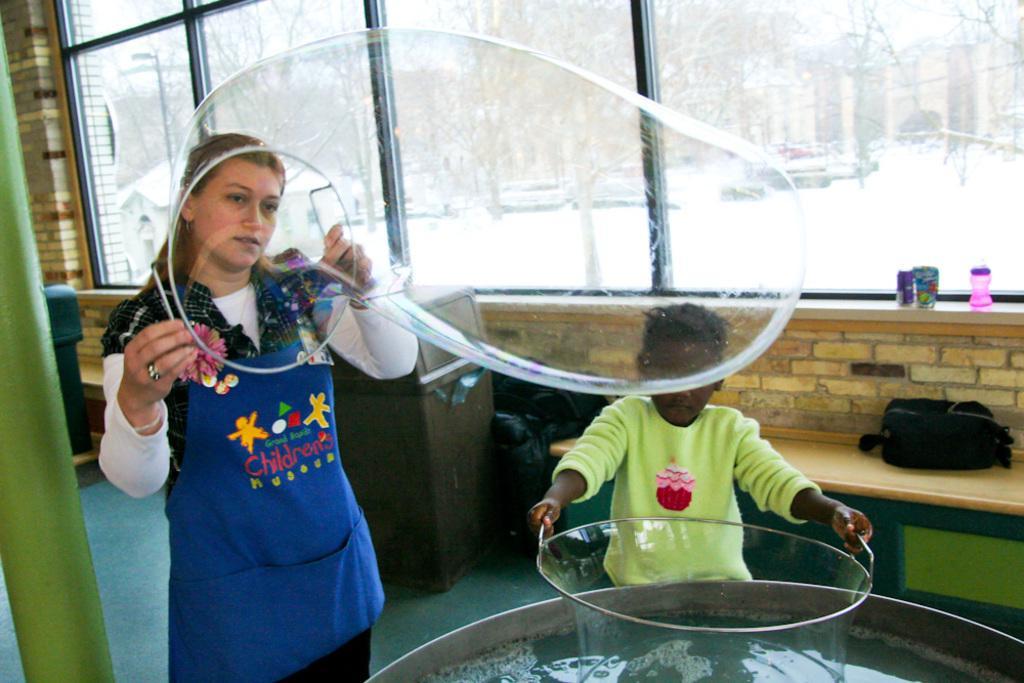In one or two sentences, can you explain what this image depicts? In front of the image there is a water in the tub. There is a person holding the tub. Beside him there is a person holding the bubble. On the left side of the image there is a pole. There is a bag on the bench. Beside the bench there are a few other objects. There is a bottle and a few other objects on the platform. In the background of the image there are glass windows through which we can see trees and buildings. 